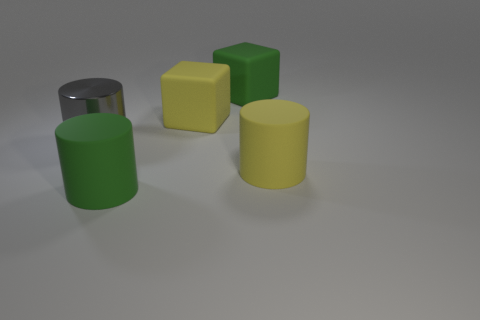Subtract all yellow rubber cylinders. How many cylinders are left? 2 Add 2 tiny yellow matte blocks. How many objects exist? 7 Subtract all green cubes. How many cubes are left? 1 Subtract all cubes. How many objects are left? 3 Subtract 1 blocks. How many blocks are left? 1 Subtract all cyan cylinders. Subtract all purple balls. How many cylinders are left? 3 Subtract all gray spheres. How many blue cylinders are left? 0 Subtract all big cylinders. Subtract all large green matte cubes. How many objects are left? 1 Add 1 green rubber cylinders. How many green rubber cylinders are left? 2 Add 2 green cylinders. How many green cylinders exist? 3 